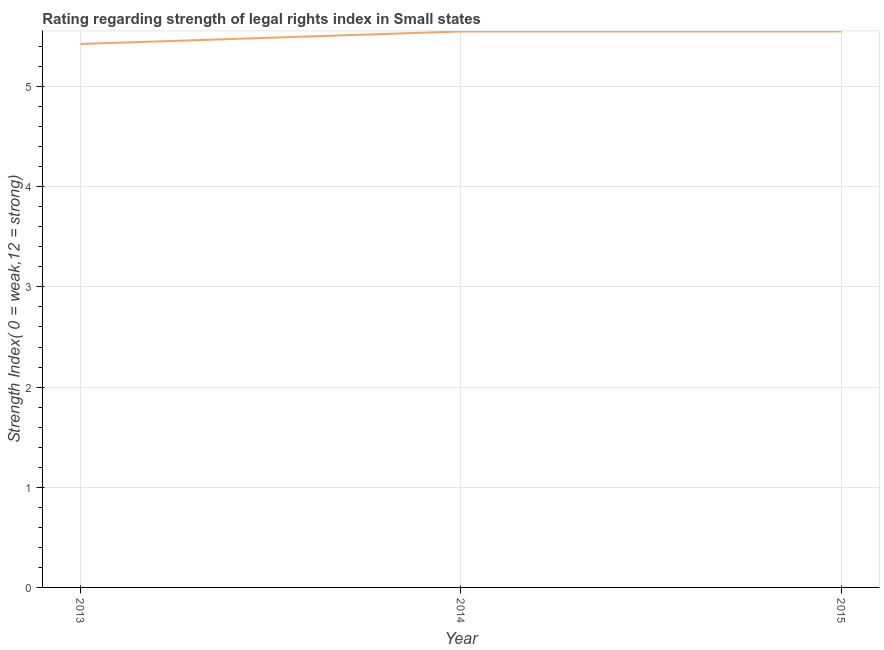What is the strength of legal rights index in 2013?
Give a very brief answer. 5.42. Across all years, what is the maximum strength of legal rights index?
Keep it short and to the point. 5.55. Across all years, what is the minimum strength of legal rights index?
Your response must be concise. 5.42. In which year was the strength of legal rights index maximum?
Ensure brevity in your answer.  2014. In which year was the strength of legal rights index minimum?
Make the answer very short. 2013. What is the sum of the strength of legal rights index?
Your answer should be compact. 16.52. What is the difference between the strength of legal rights index in 2013 and 2015?
Provide a short and direct response. -0.12. What is the average strength of legal rights index per year?
Make the answer very short. 5.51. What is the median strength of legal rights index?
Offer a very short reply. 5.55. In how many years, is the strength of legal rights index greater than 3.4 ?
Provide a short and direct response. 3. What is the ratio of the strength of legal rights index in 2013 to that in 2015?
Your answer should be very brief. 0.98. Is the sum of the strength of legal rights index in 2013 and 2015 greater than the maximum strength of legal rights index across all years?
Your answer should be compact. Yes. What is the difference between the highest and the lowest strength of legal rights index?
Keep it short and to the point. 0.12. In how many years, is the strength of legal rights index greater than the average strength of legal rights index taken over all years?
Your response must be concise. 2. Does the strength of legal rights index monotonically increase over the years?
Offer a very short reply. No. How many lines are there?
Make the answer very short. 1. Are the values on the major ticks of Y-axis written in scientific E-notation?
Keep it short and to the point. No. Does the graph contain any zero values?
Provide a succinct answer. No. Does the graph contain grids?
Keep it short and to the point. Yes. What is the title of the graph?
Make the answer very short. Rating regarding strength of legal rights index in Small states. What is the label or title of the X-axis?
Offer a terse response. Year. What is the label or title of the Y-axis?
Give a very brief answer. Strength Index( 0 = weak,12 = strong). What is the Strength Index( 0 = weak,12 = strong) in 2013?
Your response must be concise. 5.42. What is the Strength Index( 0 = weak,12 = strong) of 2014?
Your answer should be compact. 5.55. What is the Strength Index( 0 = weak,12 = strong) in 2015?
Keep it short and to the point. 5.55. What is the difference between the Strength Index( 0 = weak,12 = strong) in 2013 and 2014?
Your response must be concise. -0.12. What is the difference between the Strength Index( 0 = weak,12 = strong) in 2013 and 2015?
Your answer should be compact. -0.12. 